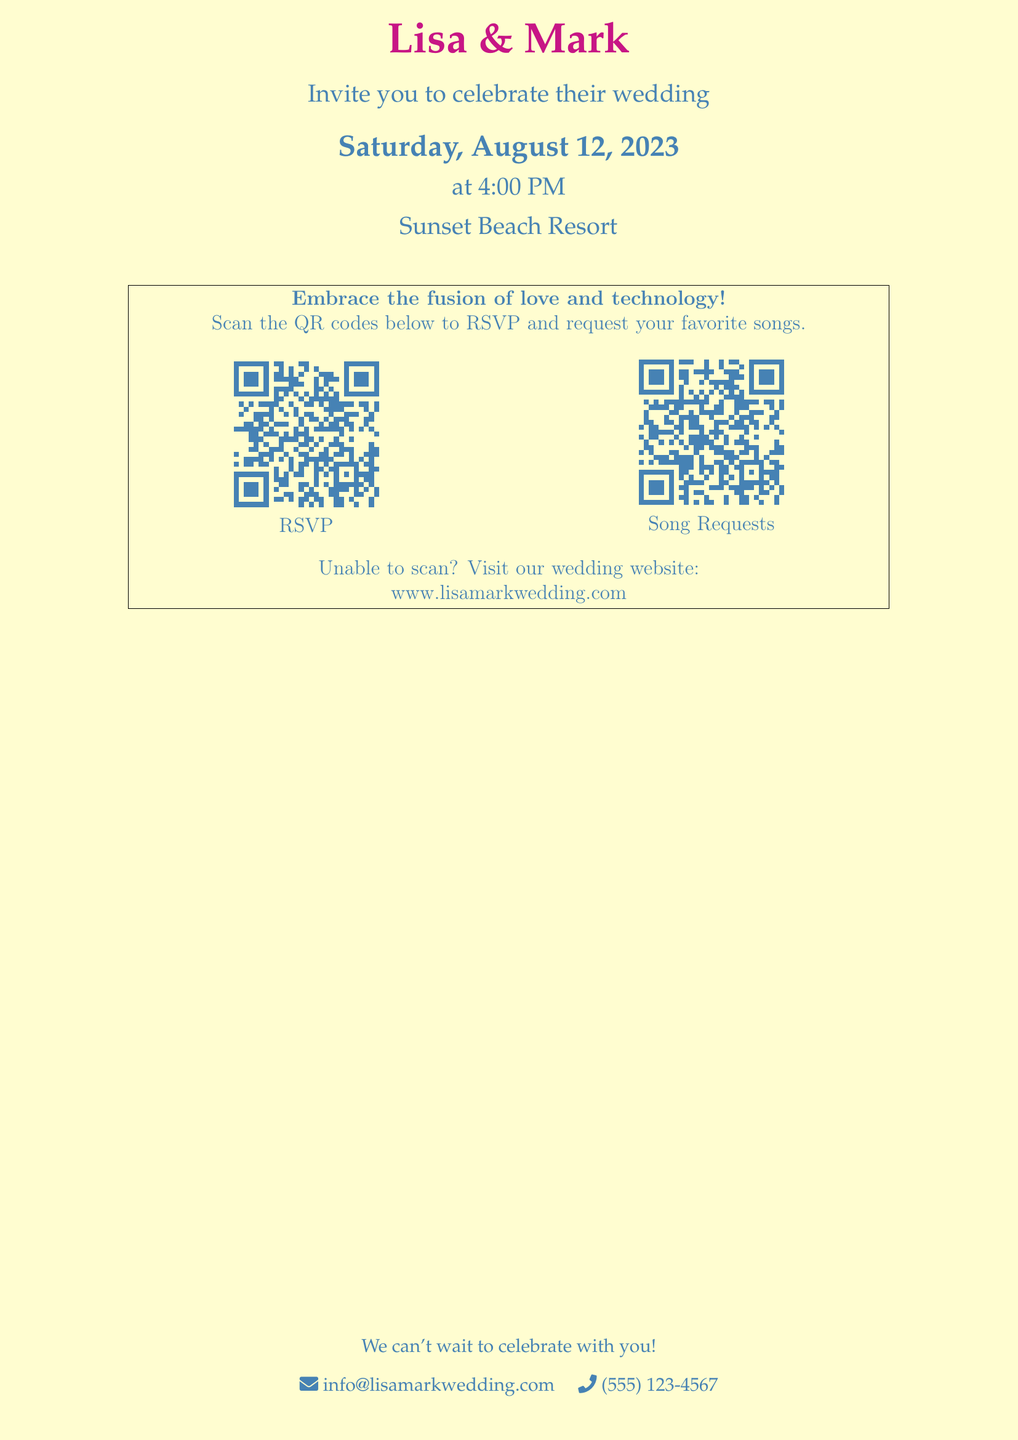What are the names of the couple? The names of the couple are Lisa and Mark, as indicated at the top of the invitation.
Answer: Lisa & Mark What date is the wedding taking place? The wedding date is specified in the document as Saturday, August 12, 2023.
Answer: August 12, 2023 What time does the wedding ceremony start? The document states that the ceremony will begin at 4:00 PM.
Answer: 4:00 PM Where is the wedding venue located? The location of the wedding is mentioned as Sunset Beach Resort.
Answer: Sunset Beach Resort What is the purpose of the QR codes included in the invitation? The QR codes are included for RSVPs and song requests from the guests, as noted in the section mentioning their usage.
Answer: RSVP and Song Requests What should guests do if they are unable to scan the QR codes? The document advises guests to visit the wedding website if they can't scan the codes.
Answer: Visit the wedding website What contact information is provided for inquiries? The invitation includes an email and phone number for inquiries, specifically info@lisamarkwedding.com and (555) 123-4567.
Answer: info@lisamarkwedding.com, (555) 123-4567 What theme does the document embrace? The document emphasizes a combination of love and technology, suggesting a modern approach to the wedding invitation.
Answer: Fusion of love and technology 